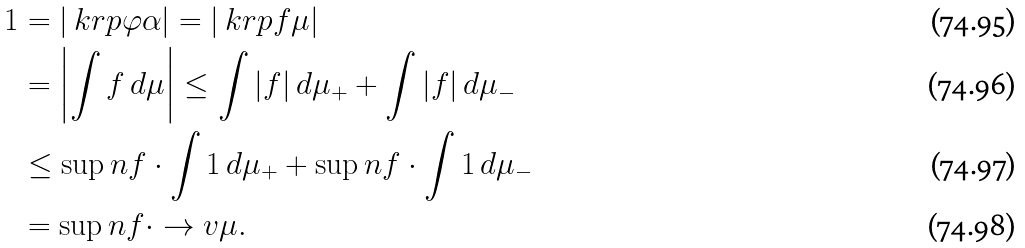Convert formula to latex. <formula><loc_0><loc_0><loc_500><loc_500>1 & = | \ k r p \varphi \alpha | = | \ k r p f \mu | \\ & = \left | \int f \, d \mu \right | \leq \int | f | \, d \mu _ { + } + \int | f | \, d \mu _ { - } \\ & \leq \sup n f \cdot \int 1 \, d \mu _ { + } + \sup n f \cdot \int 1 \, d \mu _ { - } \\ & = \sup n f \cdot \to v \mu .</formula> 